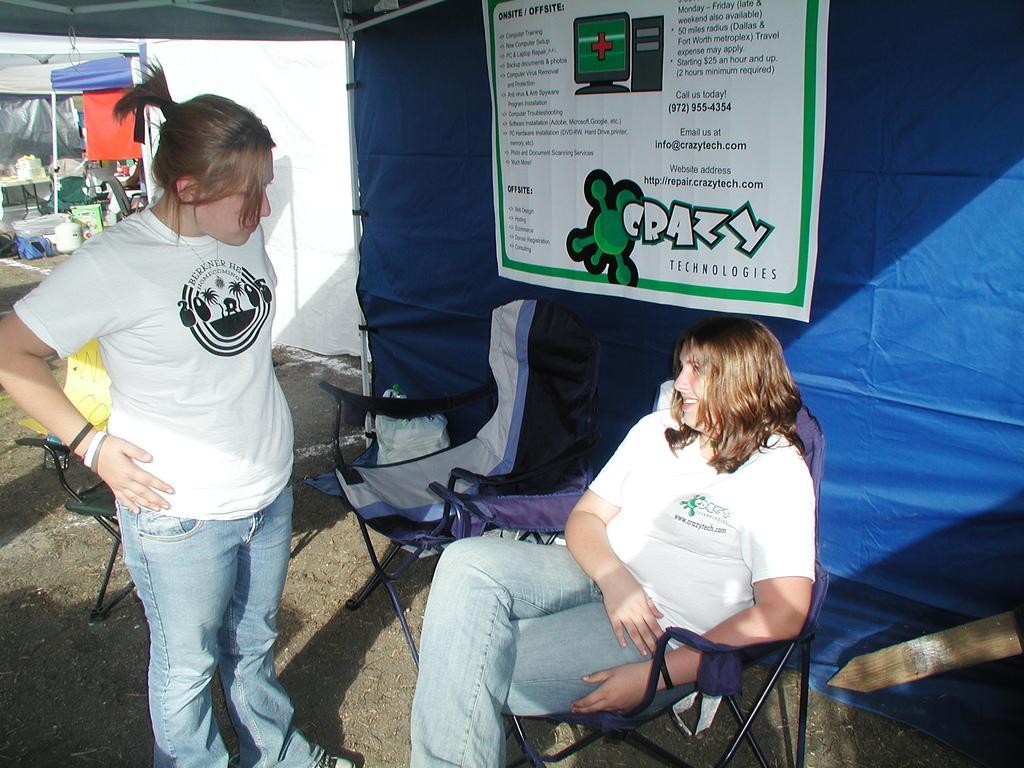In one or two sentences, can you explain what this image depicts? This image is clicked under a tent where there are two people. The one who is standing is on the left side and one person is sitting in the chair, she is in the middle of the image. Both of them over white colour t-shirt and jeans. There are chairs in this image and there is a banner behind that person who is sitting. 